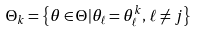Convert formula to latex. <formula><loc_0><loc_0><loc_500><loc_500>\Theta _ { k } = \left \{ \theta \in \Theta | \theta _ { \ell } = \theta ^ { k } _ { \ell } , \, \ell \neq j \right \}</formula> 